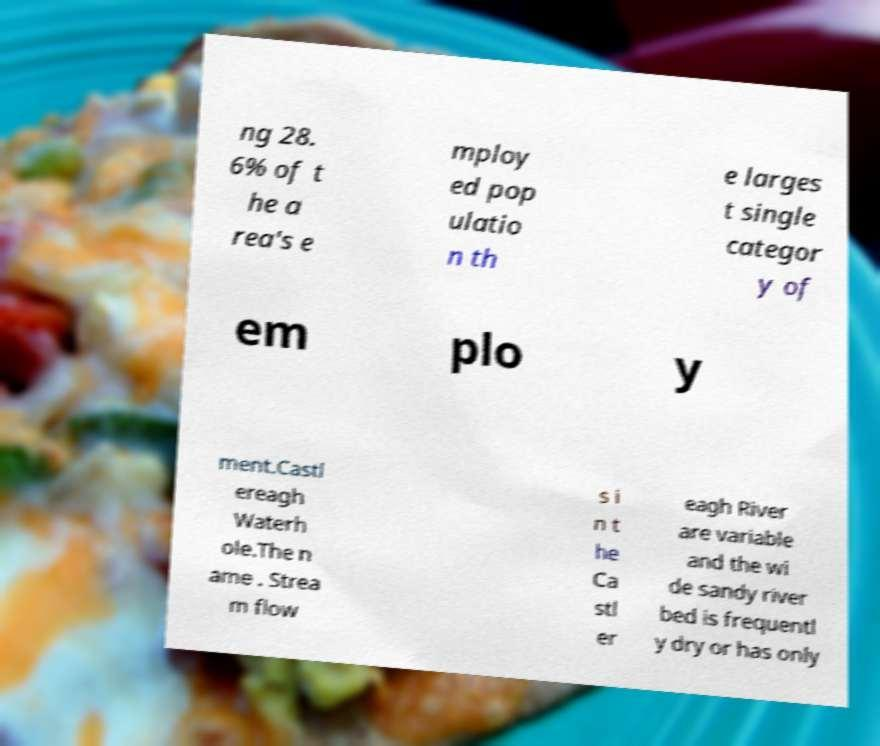What messages or text are displayed in this image? I need them in a readable, typed format. ng 28. 6% of t he a rea's e mploy ed pop ulatio n th e larges t single categor y of em plo y ment.Castl ereagh Waterh ole.The n ame . Strea m flow s i n t he Ca stl er eagh River are variable and the wi de sandy river bed is frequentl y dry or has only 